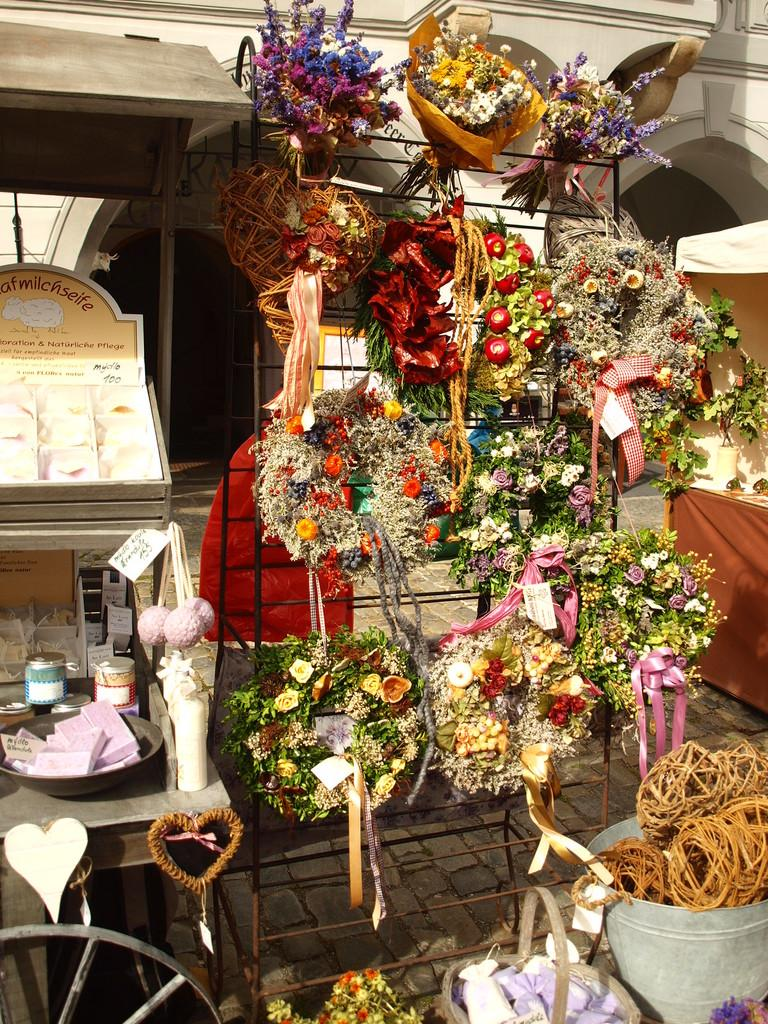How are the flower bouquets arranged in the image? The flower bouquets are arranged in a rack, a basket, a bucket, and jars. Are there any indications of the cost of the flower bouquets in the image? Yes, there are price tags associated with the flower bouquets. What additional structures can be seen in the image? There is a wheel, a tent, and a building visible in the image. Can you describe any other objects present in the image? There are other unspecified objects in the image. What type of nose can be seen on the flower bouquets in the image? There are no noses present on the flower bouquets in the image, as they are inanimate objects. 